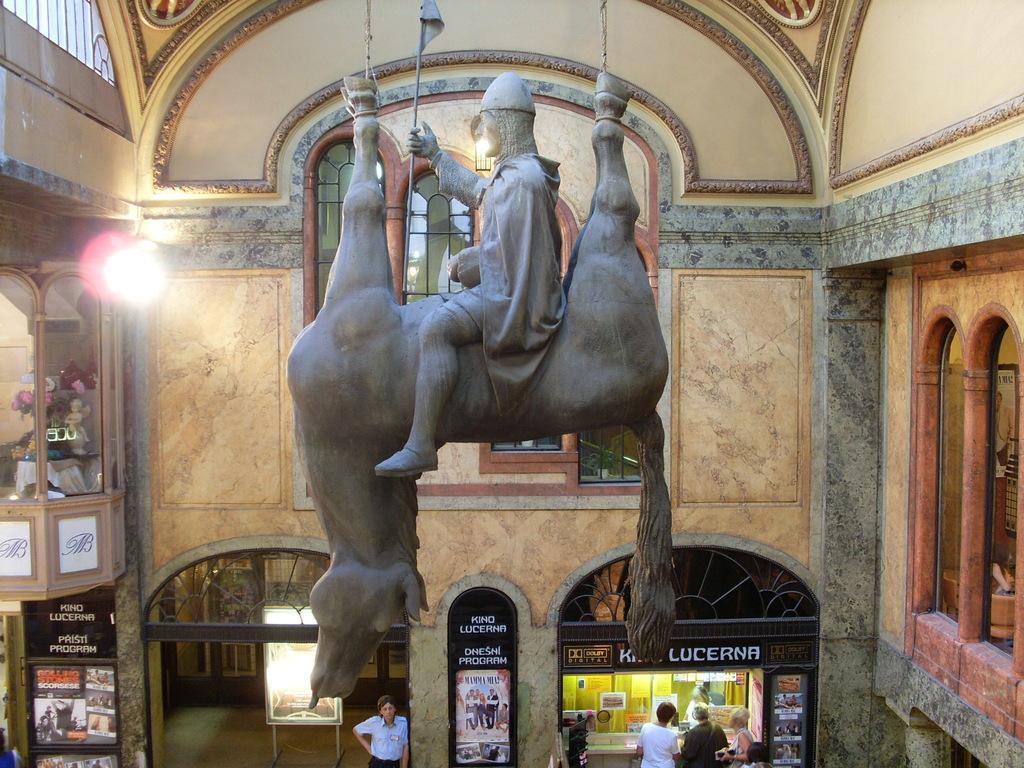How would you summarize this image in a sentence or two? In the middle it is statue of a horse in reverse shape and a man is sitting on it. At the bottom there is a store few people are standing near it. On the left side there is a light. 